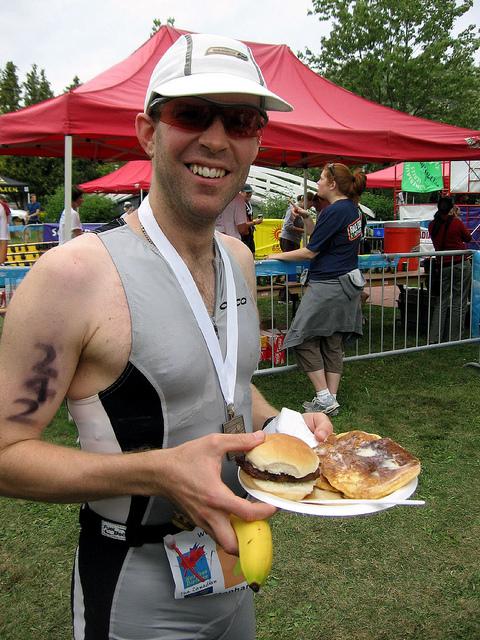Was he a participant in a race?
Quick response, please. Yes. What number is on his arm?
Write a very short answer. 242. What type of fruit is he holding?
Give a very brief answer. Banana. 